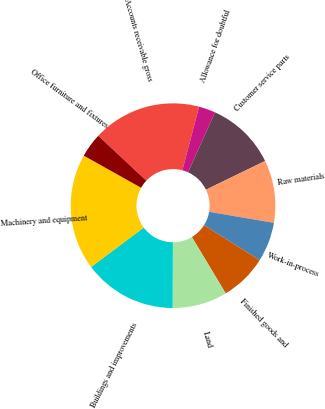Convert chart. <chart><loc_0><loc_0><loc_500><loc_500><pie_chart><fcel>Accounts receivable gross<fcel>Allowance for doubtful<fcel>Customer service parts<fcel>Raw materials<fcel>Work-in-process<fcel>Finished goods and<fcel>Land<fcel>Buildings and improvements<fcel>Machinery and equipment<fcel>Office furniture and fixtures<nl><fcel>17.14%<fcel>2.62%<fcel>11.09%<fcel>9.88%<fcel>6.25%<fcel>7.46%<fcel>8.67%<fcel>14.72%<fcel>18.35%<fcel>3.83%<nl></chart> 